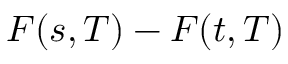Convert formula to latex. <formula><loc_0><loc_0><loc_500><loc_500>F ( s , T ) - F ( t , T )</formula> 